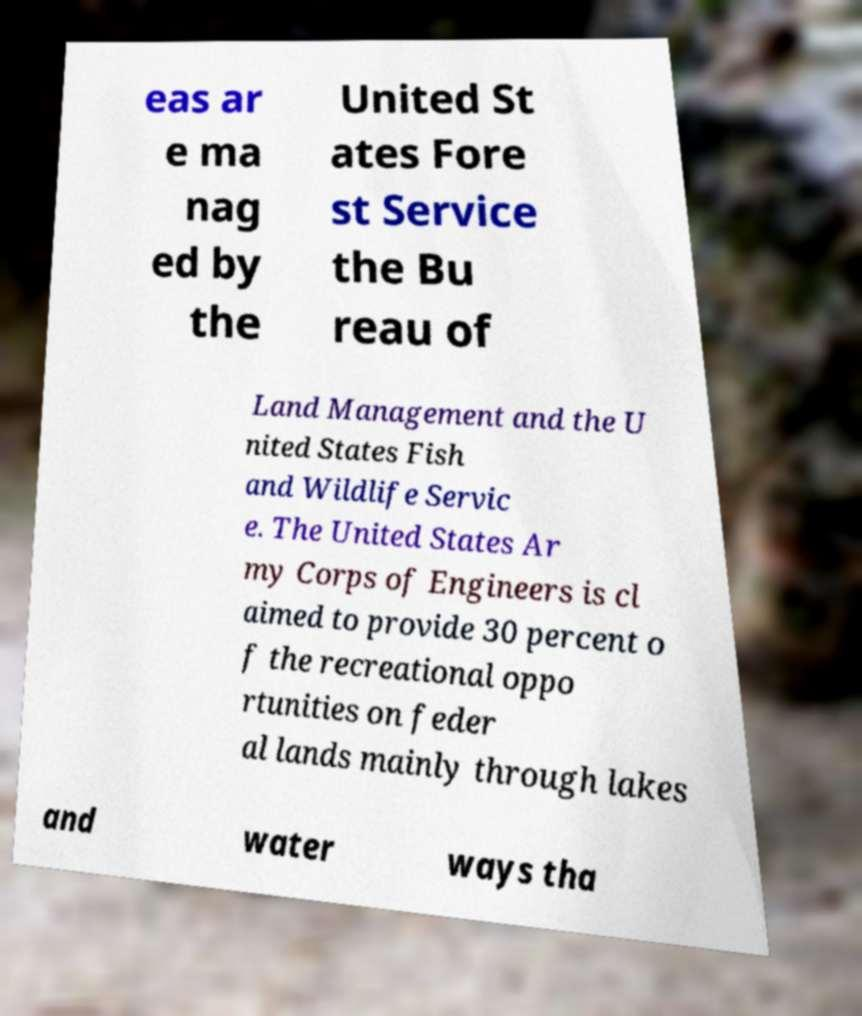Please read and relay the text visible in this image. What does it say? eas ar e ma nag ed by the United St ates Fore st Service the Bu reau of Land Management and the U nited States Fish and Wildlife Servic e. The United States Ar my Corps of Engineers is cl aimed to provide 30 percent o f the recreational oppo rtunities on feder al lands mainly through lakes and water ways tha 